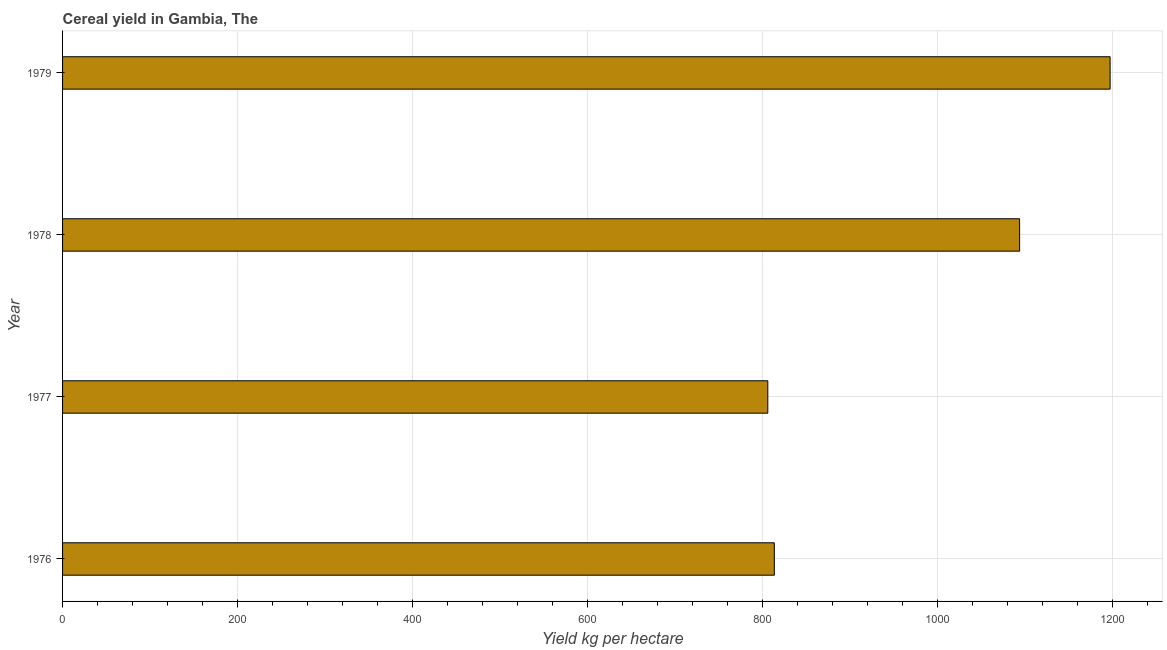Does the graph contain grids?
Provide a short and direct response. Yes. What is the title of the graph?
Give a very brief answer. Cereal yield in Gambia, The. What is the label or title of the X-axis?
Your answer should be compact. Yield kg per hectare. What is the label or title of the Y-axis?
Your answer should be very brief. Year. What is the cereal yield in 1977?
Make the answer very short. 805.85. Across all years, what is the maximum cereal yield?
Your answer should be very brief. 1197.01. Across all years, what is the minimum cereal yield?
Make the answer very short. 805.85. In which year was the cereal yield maximum?
Offer a very short reply. 1979. In which year was the cereal yield minimum?
Offer a terse response. 1977. What is the sum of the cereal yield?
Your answer should be compact. 3909.75. What is the difference between the cereal yield in 1976 and 1979?
Your response must be concise. -383.7. What is the average cereal yield per year?
Offer a very short reply. 977.44. What is the median cereal yield?
Make the answer very short. 953.45. In how many years, is the cereal yield greater than 920 kg per hectare?
Keep it short and to the point. 2. What is the ratio of the cereal yield in 1977 to that in 1979?
Offer a terse response. 0.67. What is the difference between the highest and the second highest cereal yield?
Make the answer very short. 103.42. What is the difference between the highest and the lowest cereal yield?
Your answer should be very brief. 391.16. Are all the bars in the graph horizontal?
Ensure brevity in your answer.  Yes. How many years are there in the graph?
Keep it short and to the point. 4. What is the difference between two consecutive major ticks on the X-axis?
Your answer should be compact. 200. Are the values on the major ticks of X-axis written in scientific E-notation?
Your answer should be very brief. No. What is the Yield kg per hectare of 1976?
Your answer should be compact. 813.3. What is the Yield kg per hectare of 1977?
Offer a very short reply. 805.85. What is the Yield kg per hectare in 1978?
Make the answer very short. 1093.59. What is the Yield kg per hectare of 1979?
Offer a very short reply. 1197.01. What is the difference between the Yield kg per hectare in 1976 and 1977?
Offer a terse response. 7.46. What is the difference between the Yield kg per hectare in 1976 and 1978?
Offer a terse response. -280.28. What is the difference between the Yield kg per hectare in 1976 and 1979?
Ensure brevity in your answer.  -383.7. What is the difference between the Yield kg per hectare in 1977 and 1978?
Offer a terse response. -287.74. What is the difference between the Yield kg per hectare in 1977 and 1979?
Keep it short and to the point. -391.16. What is the difference between the Yield kg per hectare in 1978 and 1979?
Provide a succinct answer. -103.42. What is the ratio of the Yield kg per hectare in 1976 to that in 1978?
Your answer should be compact. 0.74. What is the ratio of the Yield kg per hectare in 1976 to that in 1979?
Ensure brevity in your answer.  0.68. What is the ratio of the Yield kg per hectare in 1977 to that in 1978?
Make the answer very short. 0.74. What is the ratio of the Yield kg per hectare in 1977 to that in 1979?
Your answer should be very brief. 0.67. What is the ratio of the Yield kg per hectare in 1978 to that in 1979?
Offer a very short reply. 0.91. 